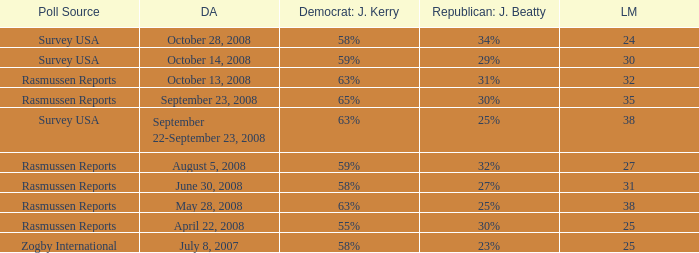Who is the poll source that has Republican: Jeff Beatty behind at 27%? Rasmussen Reports. 